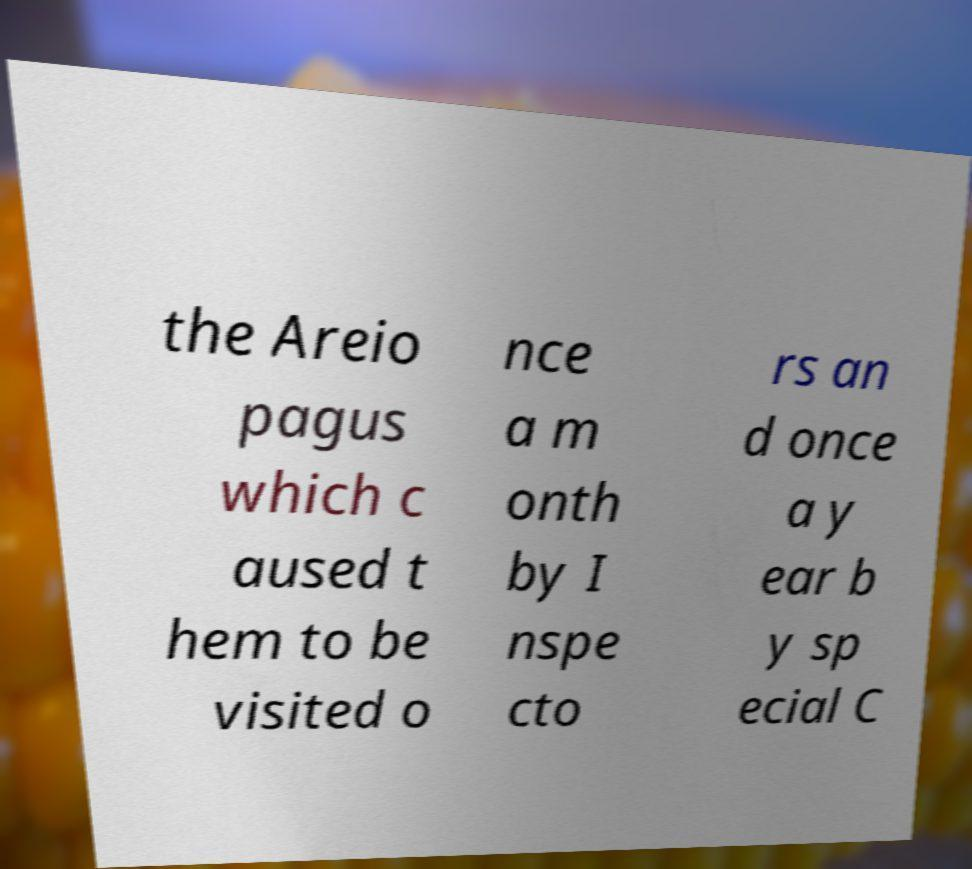There's text embedded in this image that I need extracted. Can you transcribe it verbatim? the Areio pagus which c aused t hem to be visited o nce a m onth by I nspe cto rs an d once a y ear b y sp ecial C 